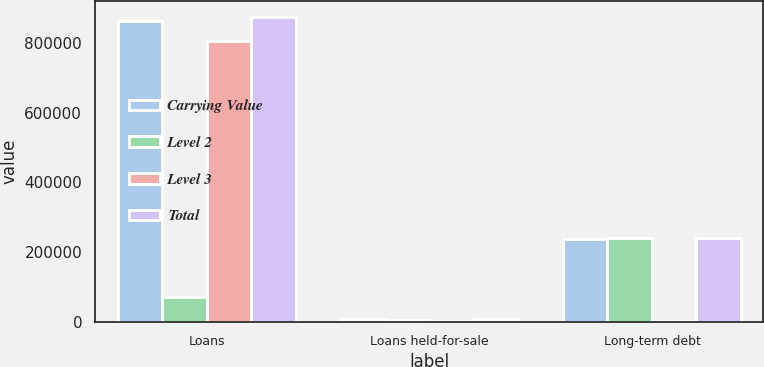<chart> <loc_0><loc_0><loc_500><loc_500><stacked_bar_chart><ecel><fcel>Loans<fcel>Loans held-for-sale<fcel>Long-term debt<nl><fcel>Carrying Value<fcel>863561<fcel>7453<fcel>236764<nl><fcel>Level 2<fcel>70223<fcel>5347<fcel>239596<nl><fcel>Level 3<fcel>805371<fcel>2106<fcel>1513<nl><fcel>Total<fcel>875594<fcel>7453<fcel>241109<nl></chart> 